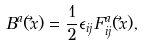<formula> <loc_0><loc_0><loc_500><loc_500>B ^ { a } ( \vec { x } ) = \frac { 1 } { 2 } \epsilon _ { i j } F _ { i j } ^ { a } ( \vec { x } ) ,</formula> 